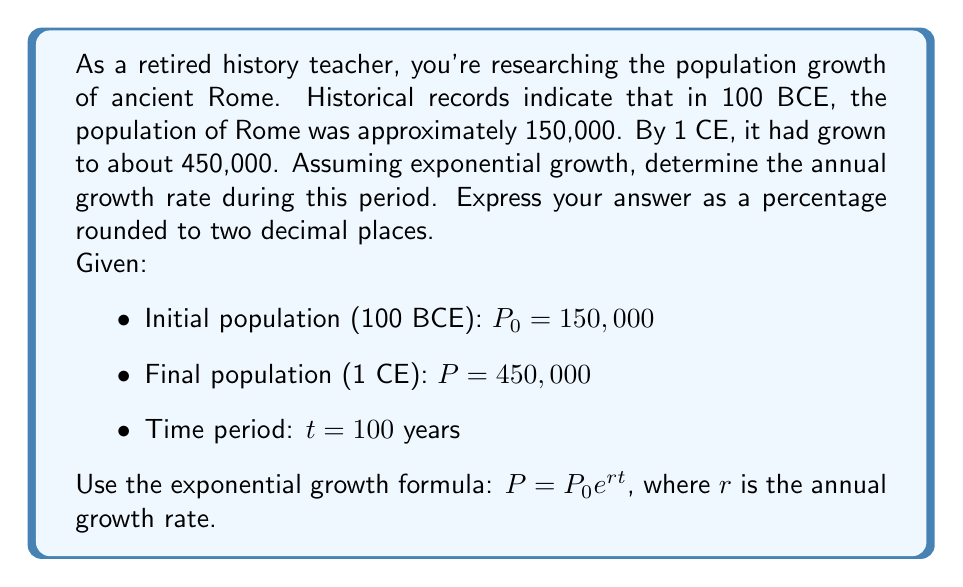Could you help me with this problem? To solve this problem, we'll use the exponential growth formula and follow these steps:

1) Start with the exponential growth formula:
   $P = P_0 e^{rt}$

2) Substitute the known values:
   $450,000 = 150,000 e^{r(100)}$

3) Divide both sides by 150,000:
   $3 = e^{100r}$

4) Take the natural logarithm of both sides:
   $\ln(3) = 100r$

5) Solve for $r$:
   $r = \frac{\ln(3)}{100}$

6) Calculate the value of $r$:
   $r = \frac{1.0986}{100} = 0.010986$

7) Convert to a percentage:
   $0.010986 \times 100 = 1.0986\%$

8) Round to two decimal places:
   $1.10\%$

This growth rate represents the average annual increase in Rome's population between 100 BCE and 1 CE, assuming continuous exponential growth.
Answer: The annual growth rate of Rome's population between 100 BCE and 1 CE was approximately $1.10\%$. 